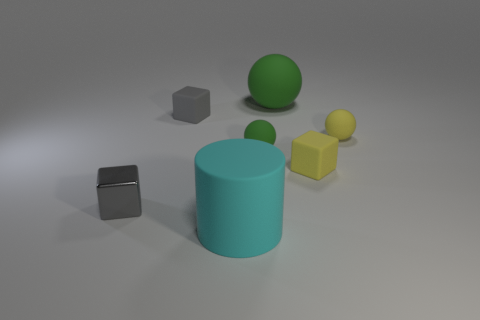Are there any large cyan cylinders?
Ensure brevity in your answer.  Yes. There is a gray thing right of the metallic cube; does it have the same size as the large green rubber thing?
Your response must be concise. No. Are there fewer shiny things than small cyan matte blocks?
Keep it short and to the point. No. There is a yellow matte thing that is behind the tiny cube that is right of the green object to the left of the large green matte ball; what shape is it?
Your answer should be compact. Sphere. Are there any other objects that have the same material as the small green thing?
Keep it short and to the point. Yes. There is a matte cube to the right of the big green matte thing; is it the same color as the large rubber thing that is left of the large green rubber ball?
Provide a succinct answer. No. Is the number of metallic objects in front of the small gray metal thing less than the number of small matte objects?
Ensure brevity in your answer.  Yes. How many things are either large rubber cylinders or small things left of the matte cylinder?
Your response must be concise. 3. What is the color of the large thing that is made of the same material as the big cylinder?
Provide a succinct answer. Green. How many things are metal blocks or big purple metal cylinders?
Offer a very short reply. 1. 